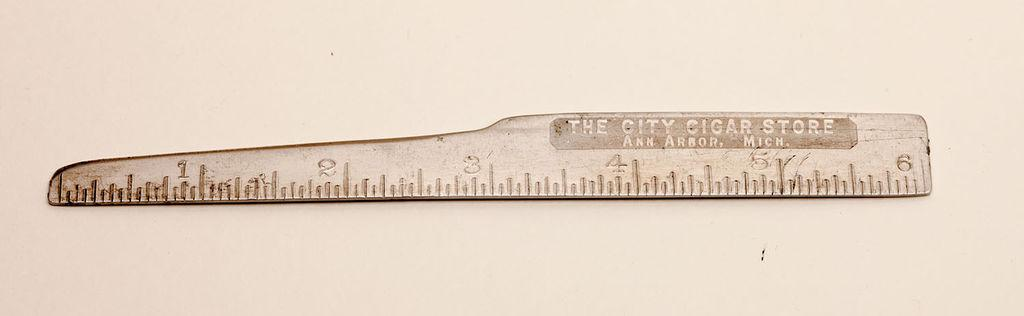<image>
Present a compact description of the photo's key features. The combination ruler and letter open came from the City Cigar Store in Ann Arbor, Michigan. 